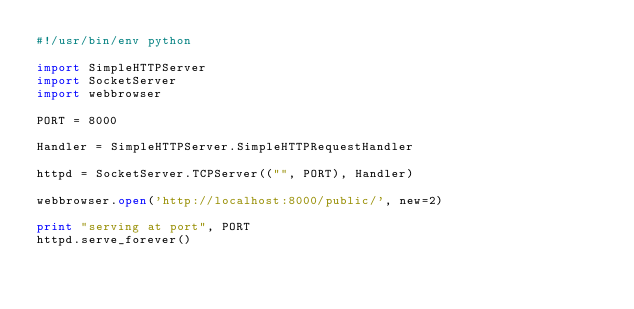<code> <loc_0><loc_0><loc_500><loc_500><_Python_>#!/usr/bin/env python

import SimpleHTTPServer
import SocketServer
import webbrowser

PORT = 8000

Handler = SimpleHTTPServer.SimpleHTTPRequestHandler

httpd = SocketServer.TCPServer(("", PORT), Handler)

webbrowser.open('http://localhost:8000/public/', new=2)

print "serving at port", PORT
httpd.serve_forever()

</code> 